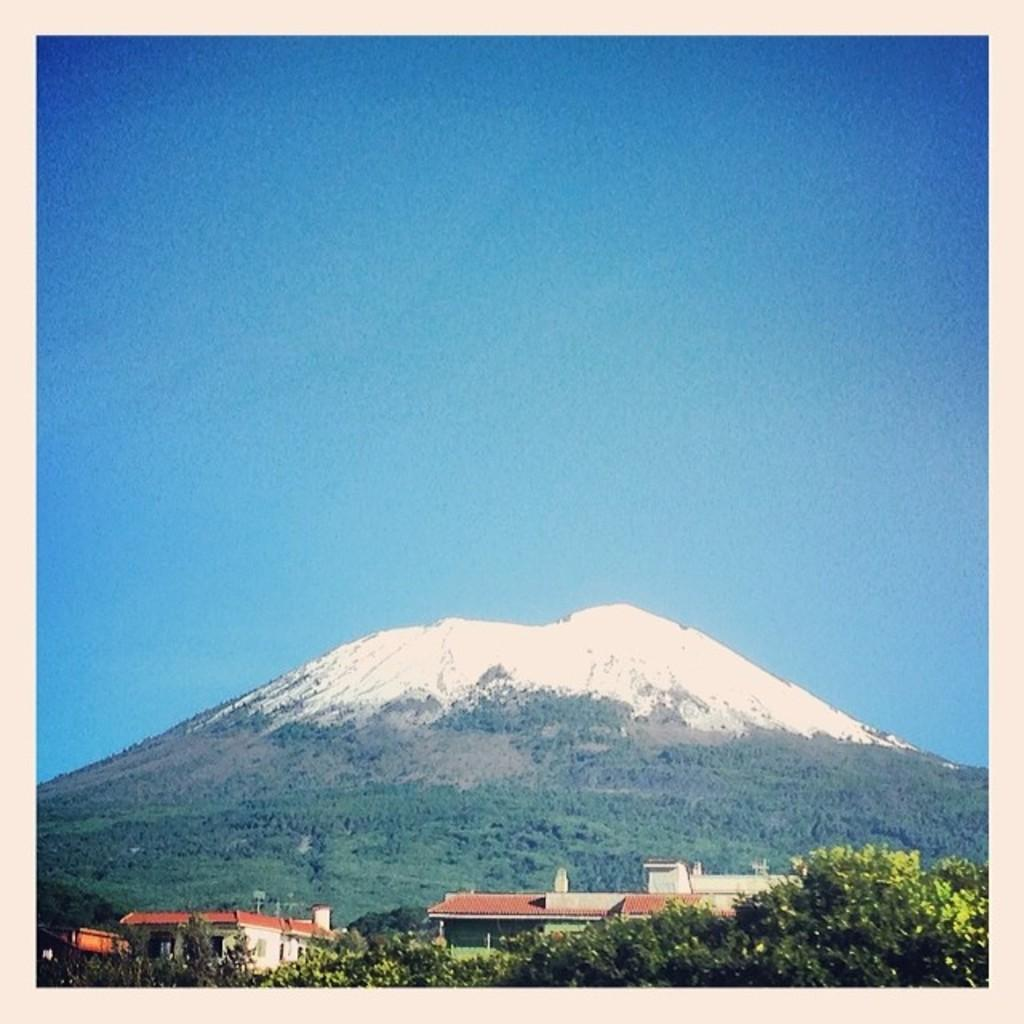What type of structures can be seen in the image? There are buildings in the image. What other natural elements are present in the image? There are trees in the image. What geographical feature is visible in the image? There is a hill in the image. What is visible at the top of the image? The sky is visible at the top of the image. What type of line can be seen connecting the buildings in the image? There is no line connecting the buildings in the image; they are separate structures. Who is the creator of the hill in the image? The hill is a natural geographical feature and not created by a specific individual. 